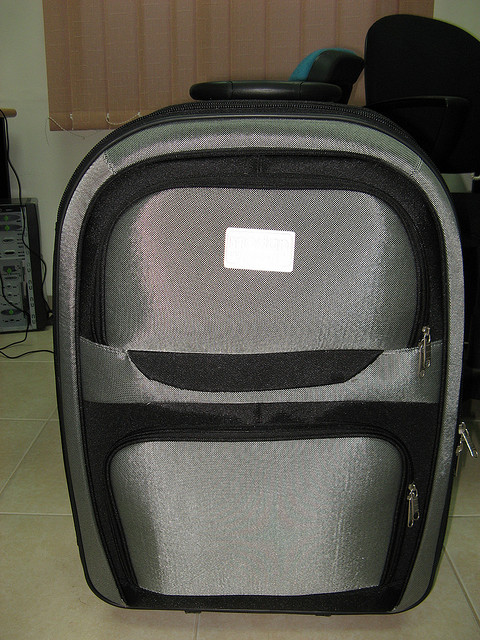<image>What material is the case? I don't know what material the case is. It could be nylon, plastic, or cloth. What material is the case? I don't know what material the case is made of. It can be nylon, plastic, cloth, fabric or a combination of plastic and cloth. 